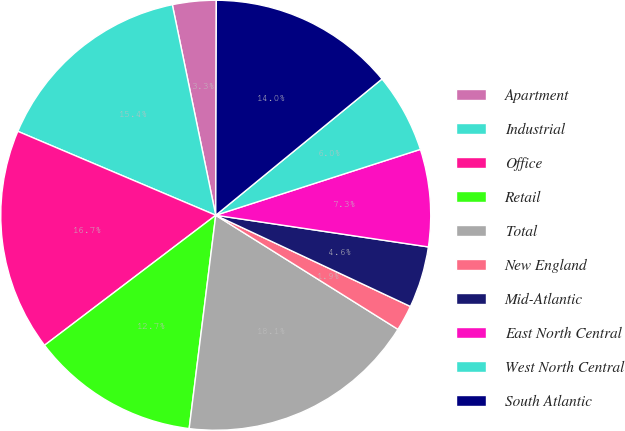Convert chart. <chart><loc_0><loc_0><loc_500><loc_500><pie_chart><fcel>Apartment<fcel>Industrial<fcel>Office<fcel>Retail<fcel>Total<fcel>New England<fcel>Mid-Atlantic<fcel>East North Central<fcel>West North Central<fcel>South Atlantic<nl><fcel>3.28%<fcel>15.38%<fcel>16.72%<fcel>12.69%<fcel>18.07%<fcel>1.93%<fcel>4.62%<fcel>7.31%<fcel>5.97%<fcel>14.03%<nl></chart> 